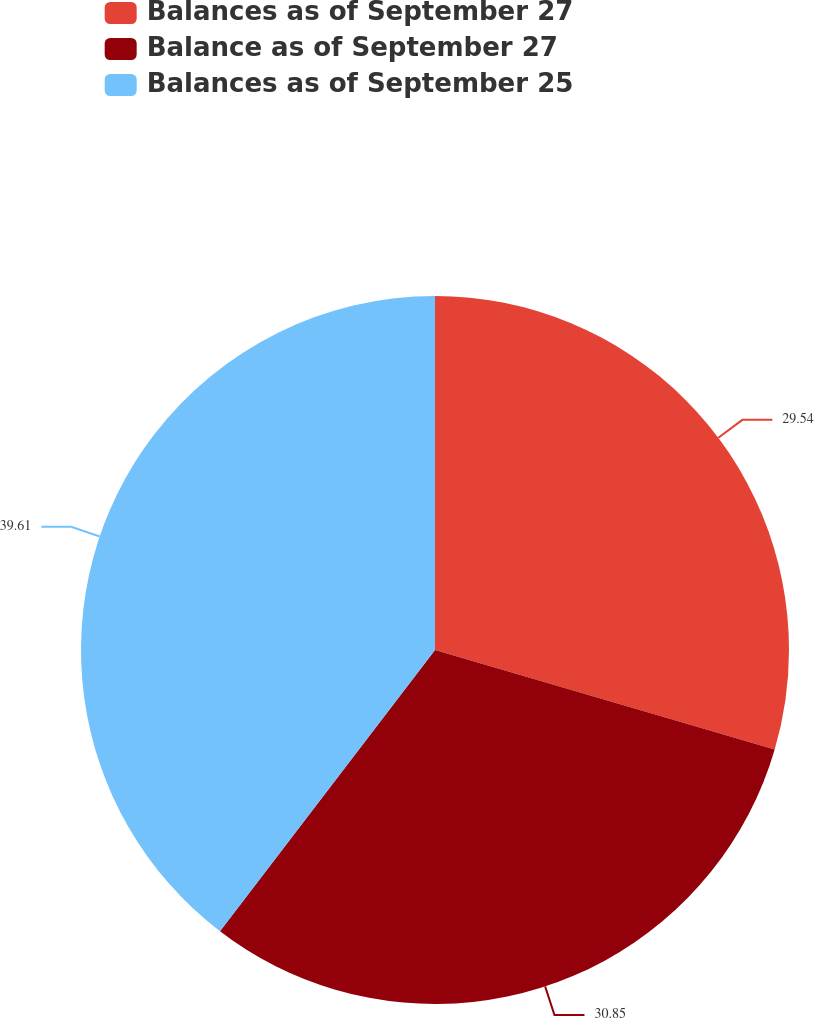Convert chart to OTSL. <chart><loc_0><loc_0><loc_500><loc_500><pie_chart><fcel>Balances as of September 27<fcel>Balance as of September 27<fcel>Balances as of September 25<nl><fcel>29.54%<fcel>30.85%<fcel>39.61%<nl></chart> 